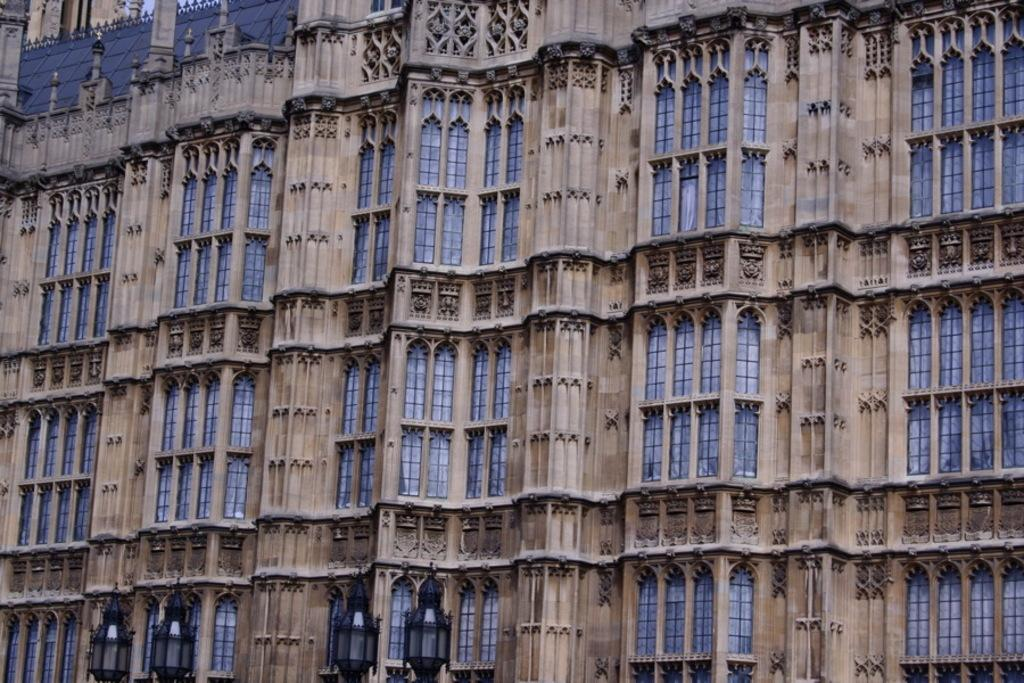What type of structures can be seen in the image? There are buildings in the image. What feature is present on the buildings? There are windows in the image. What type of lighting is present in the image? There are street lamps in the image. What type of pies are being sold at the train station in the image? There is no train station or pies present in the image; it only features buildings, windows, and street lamps. 